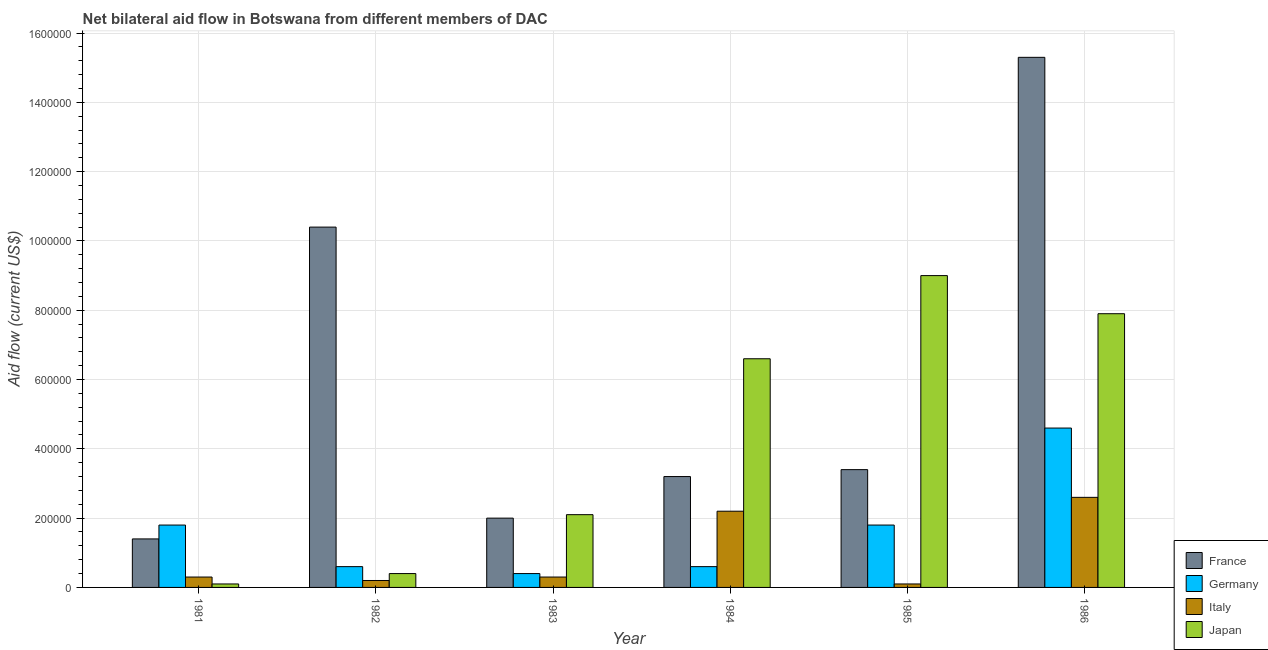How many groups of bars are there?
Make the answer very short. 6. Are the number of bars per tick equal to the number of legend labels?
Offer a very short reply. Yes. Are the number of bars on each tick of the X-axis equal?
Give a very brief answer. Yes. What is the amount of aid given by italy in 1983?
Make the answer very short. 3.00e+04. Across all years, what is the maximum amount of aid given by france?
Ensure brevity in your answer.  1.53e+06. Across all years, what is the minimum amount of aid given by japan?
Keep it short and to the point. 10000. What is the total amount of aid given by japan in the graph?
Keep it short and to the point. 2.61e+06. What is the difference between the amount of aid given by france in 1984 and that in 1986?
Provide a succinct answer. -1.21e+06. What is the difference between the amount of aid given by italy in 1985 and the amount of aid given by japan in 1983?
Offer a terse response. -2.00e+04. What is the average amount of aid given by france per year?
Your answer should be very brief. 5.95e+05. In how many years, is the amount of aid given by france greater than 880000 US$?
Provide a succinct answer. 2. What is the ratio of the amount of aid given by france in 1982 to that in 1986?
Keep it short and to the point. 0.68. Is the amount of aid given by germany in 1983 less than that in 1986?
Keep it short and to the point. Yes. What is the difference between the highest and the lowest amount of aid given by japan?
Your answer should be very brief. 8.90e+05. What does the 4th bar from the left in 1985 represents?
Ensure brevity in your answer.  Japan. Is it the case that in every year, the sum of the amount of aid given by france and amount of aid given by germany is greater than the amount of aid given by italy?
Make the answer very short. Yes. Are all the bars in the graph horizontal?
Your answer should be very brief. No. What is the difference between two consecutive major ticks on the Y-axis?
Provide a short and direct response. 2.00e+05. Are the values on the major ticks of Y-axis written in scientific E-notation?
Provide a short and direct response. No. Does the graph contain any zero values?
Give a very brief answer. No. Where does the legend appear in the graph?
Keep it short and to the point. Bottom right. How many legend labels are there?
Keep it short and to the point. 4. What is the title of the graph?
Your answer should be compact. Net bilateral aid flow in Botswana from different members of DAC. What is the label or title of the Y-axis?
Provide a succinct answer. Aid flow (current US$). What is the Aid flow (current US$) of Germany in 1981?
Make the answer very short. 1.80e+05. What is the Aid flow (current US$) of Japan in 1981?
Keep it short and to the point. 10000. What is the Aid flow (current US$) in France in 1982?
Your answer should be compact. 1.04e+06. What is the Aid flow (current US$) in Italy in 1982?
Provide a succinct answer. 2.00e+04. What is the Aid flow (current US$) of France in 1983?
Give a very brief answer. 2.00e+05. What is the Aid flow (current US$) in Germany in 1983?
Give a very brief answer. 4.00e+04. What is the Aid flow (current US$) in Japan in 1983?
Your answer should be very brief. 2.10e+05. What is the Aid flow (current US$) in France in 1984?
Ensure brevity in your answer.  3.20e+05. What is the Aid flow (current US$) of Japan in 1984?
Provide a succinct answer. 6.60e+05. What is the Aid flow (current US$) of Italy in 1985?
Offer a very short reply. 10000. What is the Aid flow (current US$) of France in 1986?
Provide a short and direct response. 1.53e+06. What is the Aid flow (current US$) of Germany in 1986?
Your answer should be compact. 4.60e+05. What is the Aid flow (current US$) of Italy in 1986?
Your answer should be compact. 2.60e+05. What is the Aid flow (current US$) in Japan in 1986?
Your answer should be very brief. 7.90e+05. Across all years, what is the maximum Aid flow (current US$) of France?
Your answer should be very brief. 1.53e+06. Across all years, what is the maximum Aid flow (current US$) in Germany?
Make the answer very short. 4.60e+05. Across all years, what is the maximum Aid flow (current US$) in Japan?
Keep it short and to the point. 9.00e+05. Across all years, what is the minimum Aid flow (current US$) of France?
Keep it short and to the point. 1.40e+05. Across all years, what is the minimum Aid flow (current US$) of Italy?
Provide a short and direct response. 10000. Across all years, what is the minimum Aid flow (current US$) of Japan?
Your response must be concise. 10000. What is the total Aid flow (current US$) of France in the graph?
Your response must be concise. 3.57e+06. What is the total Aid flow (current US$) in Germany in the graph?
Make the answer very short. 9.80e+05. What is the total Aid flow (current US$) of Italy in the graph?
Your response must be concise. 5.70e+05. What is the total Aid flow (current US$) of Japan in the graph?
Give a very brief answer. 2.61e+06. What is the difference between the Aid flow (current US$) of France in 1981 and that in 1982?
Your response must be concise. -9.00e+05. What is the difference between the Aid flow (current US$) in Germany in 1981 and that in 1982?
Make the answer very short. 1.20e+05. What is the difference between the Aid flow (current US$) of Japan in 1981 and that in 1982?
Give a very brief answer. -3.00e+04. What is the difference between the Aid flow (current US$) of France in 1981 and that in 1983?
Give a very brief answer. -6.00e+04. What is the difference between the Aid flow (current US$) of Japan in 1981 and that in 1983?
Offer a very short reply. -2.00e+05. What is the difference between the Aid flow (current US$) in France in 1981 and that in 1984?
Your answer should be very brief. -1.80e+05. What is the difference between the Aid flow (current US$) of Japan in 1981 and that in 1984?
Provide a short and direct response. -6.50e+05. What is the difference between the Aid flow (current US$) in France in 1981 and that in 1985?
Offer a terse response. -2.00e+05. What is the difference between the Aid flow (current US$) of Italy in 1981 and that in 1985?
Your answer should be compact. 2.00e+04. What is the difference between the Aid flow (current US$) of Japan in 1981 and that in 1985?
Keep it short and to the point. -8.90e+05. What is the difference between the Aid flow (current US$) in France in 1981 and that in 1986?
Your answer should be compact. -1.39e+06. What is the difference between the Aid flow (current US$) in Germany in 1981 and that in 1986?
Offer a very short reply. -2.80e+05. What is the difference between the Aid flow (current US$) in Japan in 1981 and that in 1986?
Your response must be concise. -7.80e+05. What is the difference between the Aid flow (current US$) of France in 1982 and that in 1983?
Make the answer very short. 8.40e+05. What is the difference between the Aid flow (current US$) in Germany in 1982 and that in 1983?
Give a very brief answer. 2.00e+04. What is the difference between the Aid flow (current US$) of France in 1982 and that in 1984?
Keep it short and to the point. 7.20e+05. What is the difference between the Aid flow (current US$) of Japan in 1982 and that in 1984?
Your answer should be compact. -6.20e+05. What is the difference between the Aid flow (current US$) in France in 1982 and that in 1985?
Offer a very short reply. 7.00e+05. What is the difference between the Aid flow (current US$) in Germany in 1982 and that in 1985?
Offer a terse response. -1.20e+05. What is the difference between the Aid flow (current US$) of Japan in 1982 and that in 1985?
Your answer should be compact. -8.60e+05. What is the difference between the Aid flow (current US$) of France in 1982 and that in 1986?
Your answer should be very brief. -4.90e+05. What is the difference between the Aid flow (current US$) of Germany in 1982 and that in 1986?
Your answer should be compact. -4.00e+05. What is the difference between the Aid flow (current US$) in Japan in 1982 and that in 1986?
Provide a short and direct response. -7.50e+05. What is the difference between the Aid flow (current US$) in Japan in 1983 and that in 1984?
Your answer should be compact. -4.50e+05. What is the difference between the Aid flow (current US$) in France in 1983 and that in 1985?
Make the answer very short. -1.40e+05. What is the difference between the Aid flow (current US$) in Japan in 1983 and that in 1985?
Offer a very short reply. -6.90e+05. What is the difference between the Aid flow (current US$) of France in 1983 and that in 1986?
Offer a very short reply. -1.33e+06. What is the difference between the Aid flow (current US$) in Germany in 1983 and that in 1986?
Give a very brief answer. -4.20e+05. What is the difference between the Aid flow (current US$) in Italy in 1983 and that in 1986?
Offer a terse response. -2.30e+05. What is the difference between the Aid flow (current US$) of Japan in 1983 and that in 1986?
Offer a terse response. -5.80e+05. What is the difference between the Aid flow (current US$) of France in 1984 and that in 1985?
Offer a terse response. -2.00e+04. What is the difference between the Aid flow (current US$) in Italy in 1984 and that in 1985?
Ensure brevity in your answer.  2.10e+05. What is the difference between the Aid flow (current US$) of France in 1984 and that in 1986?
Your answer should be very brief. -1.21e+06. What is the difference between the Aid flow (current US$) of Germany in 1984 and that in 1986?
Your answer should be compact. -4.00e+05. What is the difference between the Aid flow (current US$) in Italy in 1984 and that in 1986?
Offer a very short reply. -4.00e+04. What is the difference between the Aid flow (current US$) of Japan in 1984 and that in 1986?
Keep it short and to the point. -1.30e+05. What is the difference between the Aid flow (current US$) in France in 1985 and that in 1986?
Keep it short and to the point. -1.19e+06. What is the difference between the Aid flow (current US$) in Germany in 1985 and that in 1986?
Ensure brevity in your answer.  -2.80e+05. What is the difference between the Aid flow (current US$) of France in 1981 and the Aid flow (current US$) of Germany in 1982?
Make the answer very short. 8.00e+04. What is the difference between the Aid flow (current US$) of France in 1981 and the Aid flow (current US$) of Italy in 1982?
Provide a short and direct response. 1.20e+05. What is the difference between the Aid flow (current US$) of France in 1981 and the Aid flow (current US$) of Japan in 1983?
Your answer should be compact. -7.00e+04. What is the difference between the Aid flow (current US$) in Germany in 1981 and the Aid flow (current US$) in Italy in 1983?
Provide a short and direct response. 1.50e+05. What is the difference between the Aid flow (current US$) in France in 1981 and the Aid flow (current US$) in Germany in 1984?
Your answer should be compact. 8.00e+04. What is the difference between the Aid flow (current US$) in France in 1981 and the Aid flow (current US$) in Italy in 1984?
Give a very brief answer. -8.00e+04. What is the difference between the Aid flow (current US$) of France in 1981 and the Aid flow (current US$) of Japan in 1984?
Give a very brief answer. -5.20e+05. What is the difference between the Aid flow (current US$) in Germany in 1981 and the Aid flow (current US$) in Italy in 1984?
Your answer should be very brief. -4.00e+04. What is the difference between the Aid flow (current US$) in Germany in 1981 and the Aid flow (current US$) in Japan in 1984?
Provide a short and direct response. -4.80e+05. What is the difference between the Aid flow (current US$) of Italy in 1981 and the Aid flow (current US$) of Japan in 1984?
Provide a succinct answer. -6.30e+05. What is the difference between the Aid flow (current US$) of France in 1981 and the Aid flow (current US$) of Italy in 1985?
Make the answer very short. 1.30e+05. What is the difference between the Aid flow (current US$) in France in 1981 and the Aid flow (current US$) in Japan in 1985?
Keep it short and to the point. -7.60e+05. What is the difference between the Aid flow (current US$) in Germany in 1981 and the Aid flow (current US$) in Italy in 1985?
Keep it short and to the point. 1.70e+05. What is the difference between the Aid flow (current US$) in Germany in 1981 and the Aid flow (current US$) in Japan in 1985?
Your answer should be very brief. -7.20e+05. What is the difference between the Aid flow (current US$) of Italy in 1981 and the Aid flow (current US$) of Japan in 1985?
Offer a terse response. -8.70e+05. What is the difference between the Aid flow (current US$) in France in 1981 and the Aid flow (current US$) in Germany in 1986?
Offer a very short reply. -3.20e+05. What is the difference between the Aid flow (current US$) of France in 1981 and the Aid flow (current US$) of Italy in 1986?
Keep it short and to the point. -1.20e+05. What is the difference between the Aid flow (current US$) of France in 1981 and the Aid flow (current US$) of Japan in 1986?
Offer a very short reply. -6.50e+05. What is the difference between the Aid flow (current US$) in Germany in 1981 and the Aid flow (current US$) in Italy in 1986?
Your answer should be very brief. -8.00e+04. What is the difference between the Aid flow (current US$) of Germany in 1981 and the Aid flow (current US$) of Japan in 1986?
Your answer should be very brief. -6.10e+05. What is the difference between the Aid flow (current US$) of Italy in 1981 and the Aid flow (current US$) of Japan in 1986?
Keep it short and to the point. -7.60e+05. What is the difference between the Aid flow (current US$) in France in 1982 and the Aid flow (current US$) in Germany in 1983?
Your answer should be compact. 1.00e+06. What is the difference between the Aid flow (current US$) of France in 1982 and the Aid flow (current US$) of Italy in 1983?
Give a very brief answer. 1.01e+06. What is the difference between the Aid flow (current US$) in France in 1982 and the Aid flow (current US$) in Japan in 1983?
Provide a short and direct response. 8.30e+05. What is the difference between the Aid flow (current US$) in Germany in 1982 and the Aid flow (current US$) in Italy in 1983?
Your answer should be compact. 3.00e+04. What is the difference between the Aid flow (current US$) of Germany in 1982 and the Aid flow (current US$) of Japan in 1983?
Your answer should be very brief. -1.50e+05. What is the difference between the Aid flow (current US$) in Italy in 1982 and the Aid flow (current US$) in Japan in 1983?
Offer a very short reply. -1.90e+05. What is the difference between the Aid flow (current US$) in France in 1982 and the Aid flow (current US$) in Germany in 1984?
Offer a terse response. 9.80e+05. What is the difference between the Aid flow (current US$) of France in 1982 and the Aid flow (current US$) of Italy in 1984?
Keep it short and to the point. 8.20e+05. What is the difference between the Aid flow (current US$) of France in 1982 and the Aid flow (current US$) of Japan in 1984?
Keep it short and to the point. 3.80e+05. What is the difference between the Aid flow (current US$) of Germany in 1982 and the Aid flow (current US$) of Japan in 1984?
Offer a very short reply. -6.00e+05. What is the difference between the Aid flow (current US$) in Italy in 1982 and the Aid flow (current US$) in Japan in 1984?
Your answer should be very brief. -6.40e+05. What is the difference between the Aid flow (current US$) of France in 1982 and the Aid flow (current US$) of Germany in 1985?
Make the answer very short. 8.60e+05. What is the difference between the Aid flow (current US$) in France in 1982 and the Aid flow (current US$) in Italy in 1985?
Make the answer very short. 1.03e+06. What is the difference between the Aid flow (current US$) in France in 1982 and the Aid flow (current US$) in Japan in 1985?
Your response must be concise. 1.40e+05. What is the difference between the Aid flow (current US$) in Germany in 1982 and the Aid flow (current US$) in Japan in 1985?
Offer a very short reply. -8.40e+05. What is the difference between the Aid flow (current US$) in Italy in 1982 and the Aid flow (current US$) in Japan in 1985?
Offer a very short reply. -8.80e+05. What is the difference between the Aid flow (current US$) in France in 1982 and the Aid flow (current US$) in Germany in 1986?
Offer a very short reply. 5.80e+05. What is the difference between the Aid flow (current US$) in France in 1982 and the Aid flow (current US$) in Italy in 1986?
Offer a terse response. 7.80e+05. What is the difference between the Aid flow (current US$) of France in 1982 and the Aid flow (current US$) of Japan in 1986?
Offer a very short reply. 2.50e+05. What is the difference between the Aid flow (current US$) of Germany in 1982 and the Aid flow (current US$) of Italy in 1986?
Your answer should be compact. -2.00e+05. What is the difference between the Aid flow (current US$) in Germany in 1982 and the Aid flow (current US$) in Japan in 1986?
Your answer should be very brief. -7.30e+05. What is the difference between the Aid flow (current US$) of Italy in 1982 and the Aid flow (current US$) of Japan in 1986?
Your response must be concise. -7.70e+05. What is the difference between the Aid flow (current US$) of France in 1983 and the Aid flow (current US$) of Japan in 1984?
Keep it short and to the point. -4.60e+05. What is the difference between the Aid flow (current US$) of Germany in 1983 and the Aid flow (current US$) of Italy in 1984?
Give a very brief answer. -1.80e+05. What is the difference between the Aid flow (current US$) in Germany in 1983 and the Aid flow (current US$) in Japan in 1984?
Keep it short and to the point. -6.20e+05. What is the difference between the Aid flow (current US$) of Italy in 1983 and the Aid flow (current US$) of Japan in 1984?
Ensure brevity in your answer.  -6.30e+05. What is the difference between the Aid flow (current US$) in France in 1983 and the Aid flow (current US$) in Germany in 1985?
Make the answer very short. 2.00e+04. What is the difference between the Aid flow (current US$) in France in 1983 and the Aid flow (current US$) in Japan in 1985?
Provide a succinct answer. -7.00e+05. What is the difference between the Aid flow (current US$) of Germany in 1983 and the Aid flow (current US$) of Italy in 1985?
Your answer should be very brief. 3.00e+04. What is the difference between the Aid flow (current US$) in Germany in 1983 and the Aid flow (current US$) in Japan in 1985?
Provide a short and direct response. -8.60e+05. What is the difference between the Aid flow (current US$) of Italy in 1983 and the Aid flow (current US$) of Japan in 1985?
Your response must be concise. -8.70e+05. What is the difference between the Aid flow (current US$) in France in 1983 and the Aid flow (current US$) in Italy in 1986?
Keep it short and to the point. -6.00e+04. What is the difference between the Aid flow (current US$) of France in 1983 and the Aid flow (current US$) of Japan in 1986?
Your answer should be very brief. -5.90e+05. What is the difference between the Aid flow (current US$) in Germany in 1983 and the Aid flow (current US$) in Japan in 1986?
Provide a succinct answer. -7.50e+05. What is the difference between the Aid flow (current US$) of Italy in 1983 and the Aid flow (current US$) of Japan in 1986?
Ensure brevity in your answer.  -7.60e+05. What is the difference between the Aid flow (current US$) of France in 1984 and the Aid flow (current US$) of Germany in 1985?
Make the answer very short. 1.40e+05. What is the difference between the Aid flow (current US$) of France in 1984 and the Aid flow (current US$) of Japan in 1985?
Provide a succinct answer. -5.80e+05. What is the difference between the Aid flow (current US$) of Germany in 1984 and the Aid flow (current US$) of Japan in 1985?
Your answer should be very brief. -8.40e+05. What is the difference between the Aid flow (current US$) in Italy in 1984 and the Aid flow (current US$) in Japan in 1985?
Offer a very short reply. -6.80e+05. What is the difference between the Aid flow (current US$) of France in 1984 and the Aid flow (current US$) of Italy in 1986?
Your answer should be very brief. 6.00e+04. What is the difference between the Aid flow (current US$) in France in 1984 and the Aid flow (current US$) in Japan in 1986?
Your response must be concise. -4.70e+05. What is the difference between the Aid flow (current US$) in Germany in 1984 and the Aid flow (current US$) in Italy in 1986?
Offer a terse response. -2.00e+05. What is the difference between the Aid flow (current US$) of Germany in 1984 and the Aid flow (current US$) of Japan in 1986?
Give a very brief answer. -7.30e+05. What is the difference between the Aid flow (current US$) in Italy in 1984 and the Aid flow (current US$) in Japan in 1986?
Give a very brief answer. -5.70e+05. What is the difference between the Aid flow (current US$) of France in 1985 and the Aid flow (current US$) of Germany in 1986?
Keep it short and to the point. -1.20e+05. What is the difference between the Aid flow (current US$) of France in 1985 and the Aid flow (current US$) of Japan in 1986?
Give a very brief answer. -4.50e+05. What is the difference between the Aid flow (current US$) in Germany in 1985 and the Aid flow (current US$) in Italy in 1986?
Give a very brief answer. -8.00e+04. What is the difference between the Aid flow (current US$) in Germany in 1985 and the Aid flow (current US$) in Japan in 1986?
Ensure brevity in your answer.  -6.10e+05. What is the difference between the Aid flow (current US$) of Italy in 1985 and the Aid flow (current US$) of Japan in 1986?
Your response must be concise. -7.80e+05. What is the average Aid flow (current US$) in France per year?
Give a very brief answer. 5.95e+05. What is the average Aid flow (current US$) in Germany per year?
Keep it short and to the point. 1.63e+05. What is the average Aid flow (current US$) of Italy per year?
Make the answer very short. 9.50e+04. What is the average Aid flow (current US$) of Japan per year?
Provide a succinct answer. 4.35e+05. In the year 1981, what is the difference between the Aid flow (current US$) of France and Aid flow (current US$) of Germany?
Provide a succinct answer. -4.00e+04. In the year 1981, what is the difference between the Aid flow (current US$) of France and Aid flow (current US$) of Italy?
Give a very brief answer. 1.10e+05. In the year 1981, what is the difference between the Aid flow (current US$) in Germany and Aid flow (current US$) in Italy?
Offer a very short reply. 1.50e+05. In the year 1981, what is the difference between the Aid flow (current US$) in Italy and Aid flow (current US$) in Japan?
Give a very brief answer. 2.00e+04. In the year 1982, what is the difference between the Aid flow (current US$) of France and Aid flow (current US$) of Germany?
Your response must be concise. 9.80e+05. In the year 1982, what is the difference between the Aid flow (current US$) of France and Aid flow (current US$) of Italy?
Ensure brevity in your answer.  1.02e+06. In the year 1982, what is the difference between the Aid flow (current US$) of Germany and Aid flow (current US$) of Italy?
Ensure brevity in your answer.  4.00e+04. In the year 1982, what is the difference between the Aid flow (current US$) in Italy and Aid flow (current US$) in Japan?
Give a very brief answer. -2.00e+04. In the year 1983, what is the difference between the Aid flow (current US$) of France and Aid flow (current US$) of Germany?
Offer a terse response. 1.60e+05. In the year 1983, what is the difference between the Aid flow (current US$) of France and Aid flow (current US$) of Italy?
Make the answer very short. 1.70e+05. In the year 1983, what is the difference between the Aid flow (current US$) of France and Aid flow (current US$) of Japan?
Provide a short and direct response. -10000. In the year 1984, what is the difference between the Aid flow (current US$) of Germany and Aid flow (current US$) of Japan?
Offer a very short reply. -6.00e+05. In the year 1984, what is the difference between the Aid flow (current US$) of Italy and Aid flow (current US$) of Japan?
Offer a terse response. -4.40e+05. In the year 1985, what is the difference between the Aid flow (current US$) of France and Aid flow (current US$) of Japan?
Ensure brevity in your answer.  -5.60e+05. In the year 1985, what is the difference between the Aid flow (current US$) in Germany and Aid flow (current US$) in Japan?
Keep it short and to the point. -7.20e+05. In the year 1985, what is the difference between the Aid flow (current US$) of Italy and Aid flow (current US$) of Japan?
Provide a short and direct response. -8.90e+05. In the year 1986, what is the difference between the Aid flow (current US$) in France and Aid flow (current US$) in Germany?
Your answer should be compact. 1.07e+06. In the year 1986, what is the difference between the Aid flow (current US$) of France and Aid flow (current US$) of Italy?
Keep it short and to the point. 1.27e+06. In the year 1986, what is the difference between the Aid flow (current US$) of France and Aid flow (current US$) of Japan?
Your answer should be compact. 7.40e+05. In the year 1986, what is the difference between the Aid flow (current US$) in Germany and Aid flow (current US$) in Japan?
Ensure brevity in your answer.  -3.30e+05. In the year 1986, what is the difference between the Aid flow (current US$) in Italy and Aid flow (current US$) in Japan?
Provide a short and direct response. -5.30e+05. What is the ratio of the Aid flow (current US$) in France in 1981 to that in 1982?
Provide a short and direct response. 0.13. What is the ratio of the Aid flow (current US$) of Germany in 1981 to that in 1982?
Your answer should be very brief. 3. What is the ratio of the Aid flow (current US$) of Italy in 1981 to that in 1982?
Offer a terse response. 1.5. What is the ratio of the Aid flow (current US$) of Japan in 1981 to that in 1982?
Your answer should be very brief. 0.25. What is the ratio of the Aid flow (current US$) of Germany in 1981 to that in 1983?
Give a very brief answer. 4.5. What is the ratio of the Aid flow (current US$) in Japan in 1981 to that in 1983?
Make the answer very short. 0.05. What is the ratio of the Aid flow (current US$) of France in 1981 to that in 1984?
Your answer should be very brief. 0.44. What is the ratio of the Aid flow (current US$) of Germany in 1981 to that in 1984?
Your answer should be compact. 3. What is the ratio of the Aid flow (current US$) of Italy in 1981 to that in 1984?
Give a very brief answer. 0.14. What is the ratio of the Aid flow (current US$) in Japan in 1981 to that in 1984?
Ensure brevity in your answer.  0.02. What is the ratio of the Aid flow (current US$) in France in 1981 to that in 1985?
Offer a very short reply. 0.41. What is the ratio of the Aid flow (current US$) in Japan in 1981 to that in 1985?
Ensure brevity in your answer.  0.01. What is the ratio of the Aid flow (current US$) of France in 1981 to that in 1986?
Your answer should be compact. 0.09. What is the ratio of the Aid flow (current US$) in Germany in 1981 to that in 1986?
Provide a succinct answer. 0.39. What is the ratio of the Aid flow (current US$) of Italy in 1981 to that in 1986?
Your answer should be compact. 0.12. What is the ratio of the Aid flow (current US$) in Japan in 1981 to that in 1986?
Provide a short and direct response. 0.01. What is the ratio of the Aid flow (current US$) in Germany in 1982 to that in 1983?
Provide a short and direct response. 1.5. What is the ratio of the Aid flow (current US$) in Italy in 1982 to that in 1983?
Your answer should be very brief. 0.67. What is the ratio of the Aid flow (current US$) in Japan in 1982 to that in 1983?
Keep it short and to the point. 0.19. What is the ratio of the Aid flow (current US$) in Italy in 1982 to that in 1984?
Your answer should be very brief. 0.09. What is the ratio of the Aid flow (current US$) in Japan in 1982 to that in 1984?
Offer a very short reply. 0.06. What is the ratio of the Aid flow (current US$) in France in 1982 to that in 1985?
Provide a short and direct response. 3.06. What is the ratio of the Aid flow (current US$) of Italy in 1982 to that in 1985?
Your answer should be compact. 2. What is the ratio of the Aid flow (current US$) of Japan in 1982 to that in 1985?
Your answer should be compact. 0.04. What is the ratio of the Aid flow (current US$) in France in 1982 to that in 1986?
Make the answer very short. 0.68. What is the ratio of the Aid flow (current US$) in Germany in 1982 to that in 1986?
Keep it short and to the point. 0.13. What is the ratio of the Aid flow (current US$) of Italy in 1982 to that in 1986?
Keep it short and to the point. 0.08. What is the ratio of the Aid flow (current US$) of Japan in 1982 to that in 1986?
Offer a very short reply. 0.05. What is the ratio of the Aid flow (current US$) in France in 1983 to that in 1984?
Provide a succinct answer. 0.62. What is the ratio of the Aid flow (current US$) in Italy in 1983 to that in 1984?
Offer a very short reply. 0.14. What is the ratio of the Aid flow (current US$) in Japan in 1983 to that in 1984?
Your response must be concise. 0.32. What is the ratio of the Aid flow (current US$) in France in 1983 to that in 1985?
Your answer should be very brief. 0.59. What is the ratio of the Aid flow (current US$) of Germany in 1983 to that in 1985?
Your response must be concise. 0.22. What is the ratio of the Aid flow (current US$) in Italy in 1983 to that in 1985?
Provide a short and direct response. 3. What is the ratio of the Aid flow (current US$) in Japan in 1983 to that in 1985?
Your response must be concise. 0.23. What is the ratio of the Aid flow (current US$) in France in 1983 to that in 1986?
Your answer should be very brief. 0.13. What is the ratio of the Aid flow (current US$) in Germany in 1983 to that in 1986?
Offer a terse response. 0.09. What is the ratio of the Aid flow (current US$) of Italy in 1983 to that in 1986?
Provide a succinct answer. 0.12. What is the ratio of the Aid flow (current US$) in Japan in 1983 to that in 1986?
Provide a succinct answer. 0.27. What is the ratio of the Aid flow (current US$) of Germany in 1984 to that in 1985?
Give a very brief answer. 0.33. What is the ratio of the Aid flow (current US$) of Japan in 1984 to that in 1985?
Ensure brevity in your answer.  0.73. What is the ratio of the Aid flow (current US$) in France in 1984 to that in 1986?
Your response must be concise. 0.21. What is the ratio of the Aid flow (current US$) of Germany in 1984 to that in 1986?
Your answer should be compact. 0.13. What is the ratio of the Aid flow (current US$) in Italy in 1984 to that in 1986?
Give a very brief answer. 0.85. What is the ratio of the Aid flow (current US$) in Japan in 1984 to that in 1986?
Provide a short and direct response. 0.84. What is the ratio of the Aid flow (current US$) in France in 1985 to that in 1986?
Offer a terse response. 0.22. What is the ratio of the Aid flow (current US$) in Germany in 1985 to that in 1986?
Keep it short and to the point. 0.39. What is the ratio of the Aid flow (current US$) of Italy in 1985 to that in 1986?
Make the answer very short. 0.04. What is the ratio of the Aid flow (current US$) of Japan in 1985 to that in 1986?
Offer a terse response. 1.14. What is the difference between the highest and the second highest Aid flow (current US$) of Germany?
Make the answer very short. 2.80e+05. What is the difference between the highest and the second highest Aid flow (current US$) of Italy?
Give a very brief answer. 4.00e+04. What is the difference between the highest and the lowest Aid flow (current US$) in France?
Provide a succinct answer. 1.39e+06. What is the difference between the highest and the lowest Aid flow (current US$) in Japan?
Provide a short and direct response. 8.90e+05. 